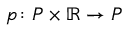<formula> <loc_0><loc_0><loc_500><loc_500>p \colon P \times \mathbb { R } \to P</formula> 